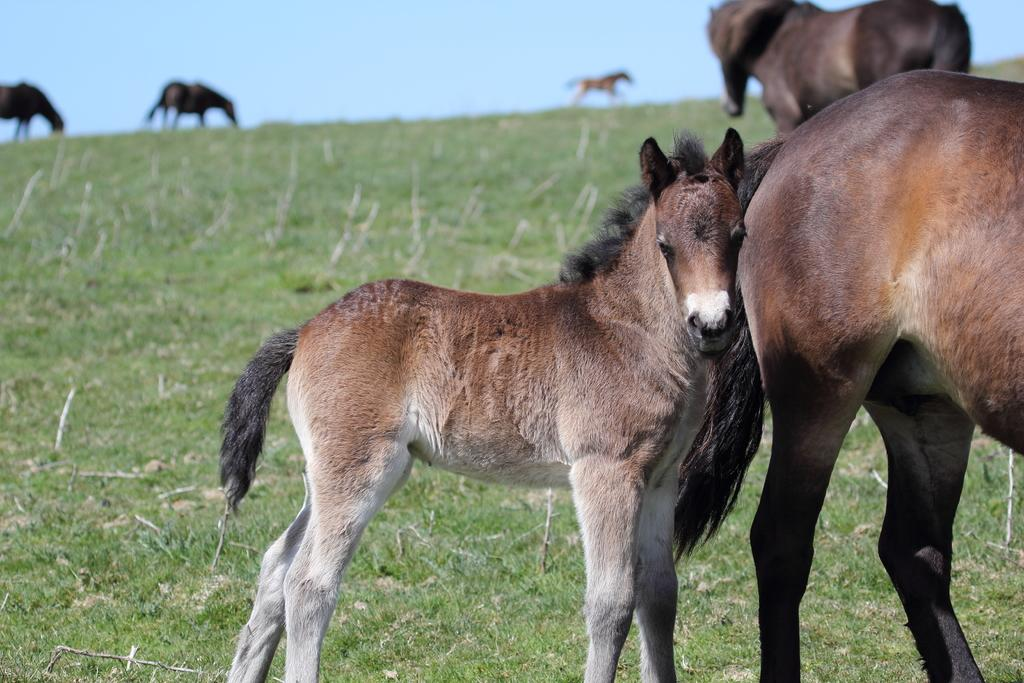What animals are present in the image? There are horses in the image. Where are the horses located? The horses are in a field. Can you describe the activity of the horses in the background? In the background, there are three horses grazing in the field. What type of rice can be seen in the image? There is no rice present in the image; it features horses in a field. How many robins are perched on the horses in the image? There are no robins present in the image. 